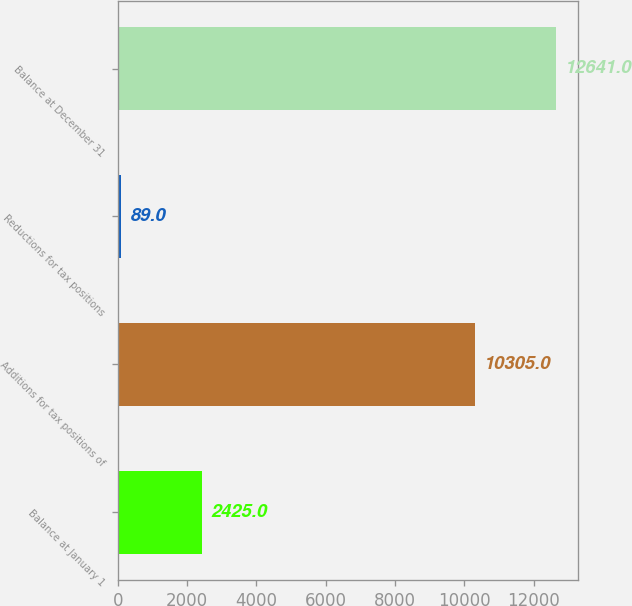Convert chart to OTSL. <chart><loc_0><loc_0><loc_500><loc_500><bar_chart><fcel>Balance at January 1<fcel>Additions for tax positions of<fcel>Reductions for tax positions<fcel>Balance at December 31<nl><fcel>2425<fcel>10305<fcel>89<fcel>12641<nl></chart> 